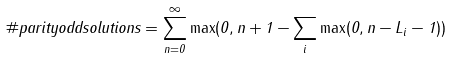<formula> <loc_0><loc_0><loc_500><loc_500>\# p a r i t y o d d s o l u t i o n s = \sum _ { n = 0 } ^ { \infty } \max ( 0 , n + 1 - \sum _ { i } \max ( 0 , n - L _ { i } - 1 ) )</formula> 